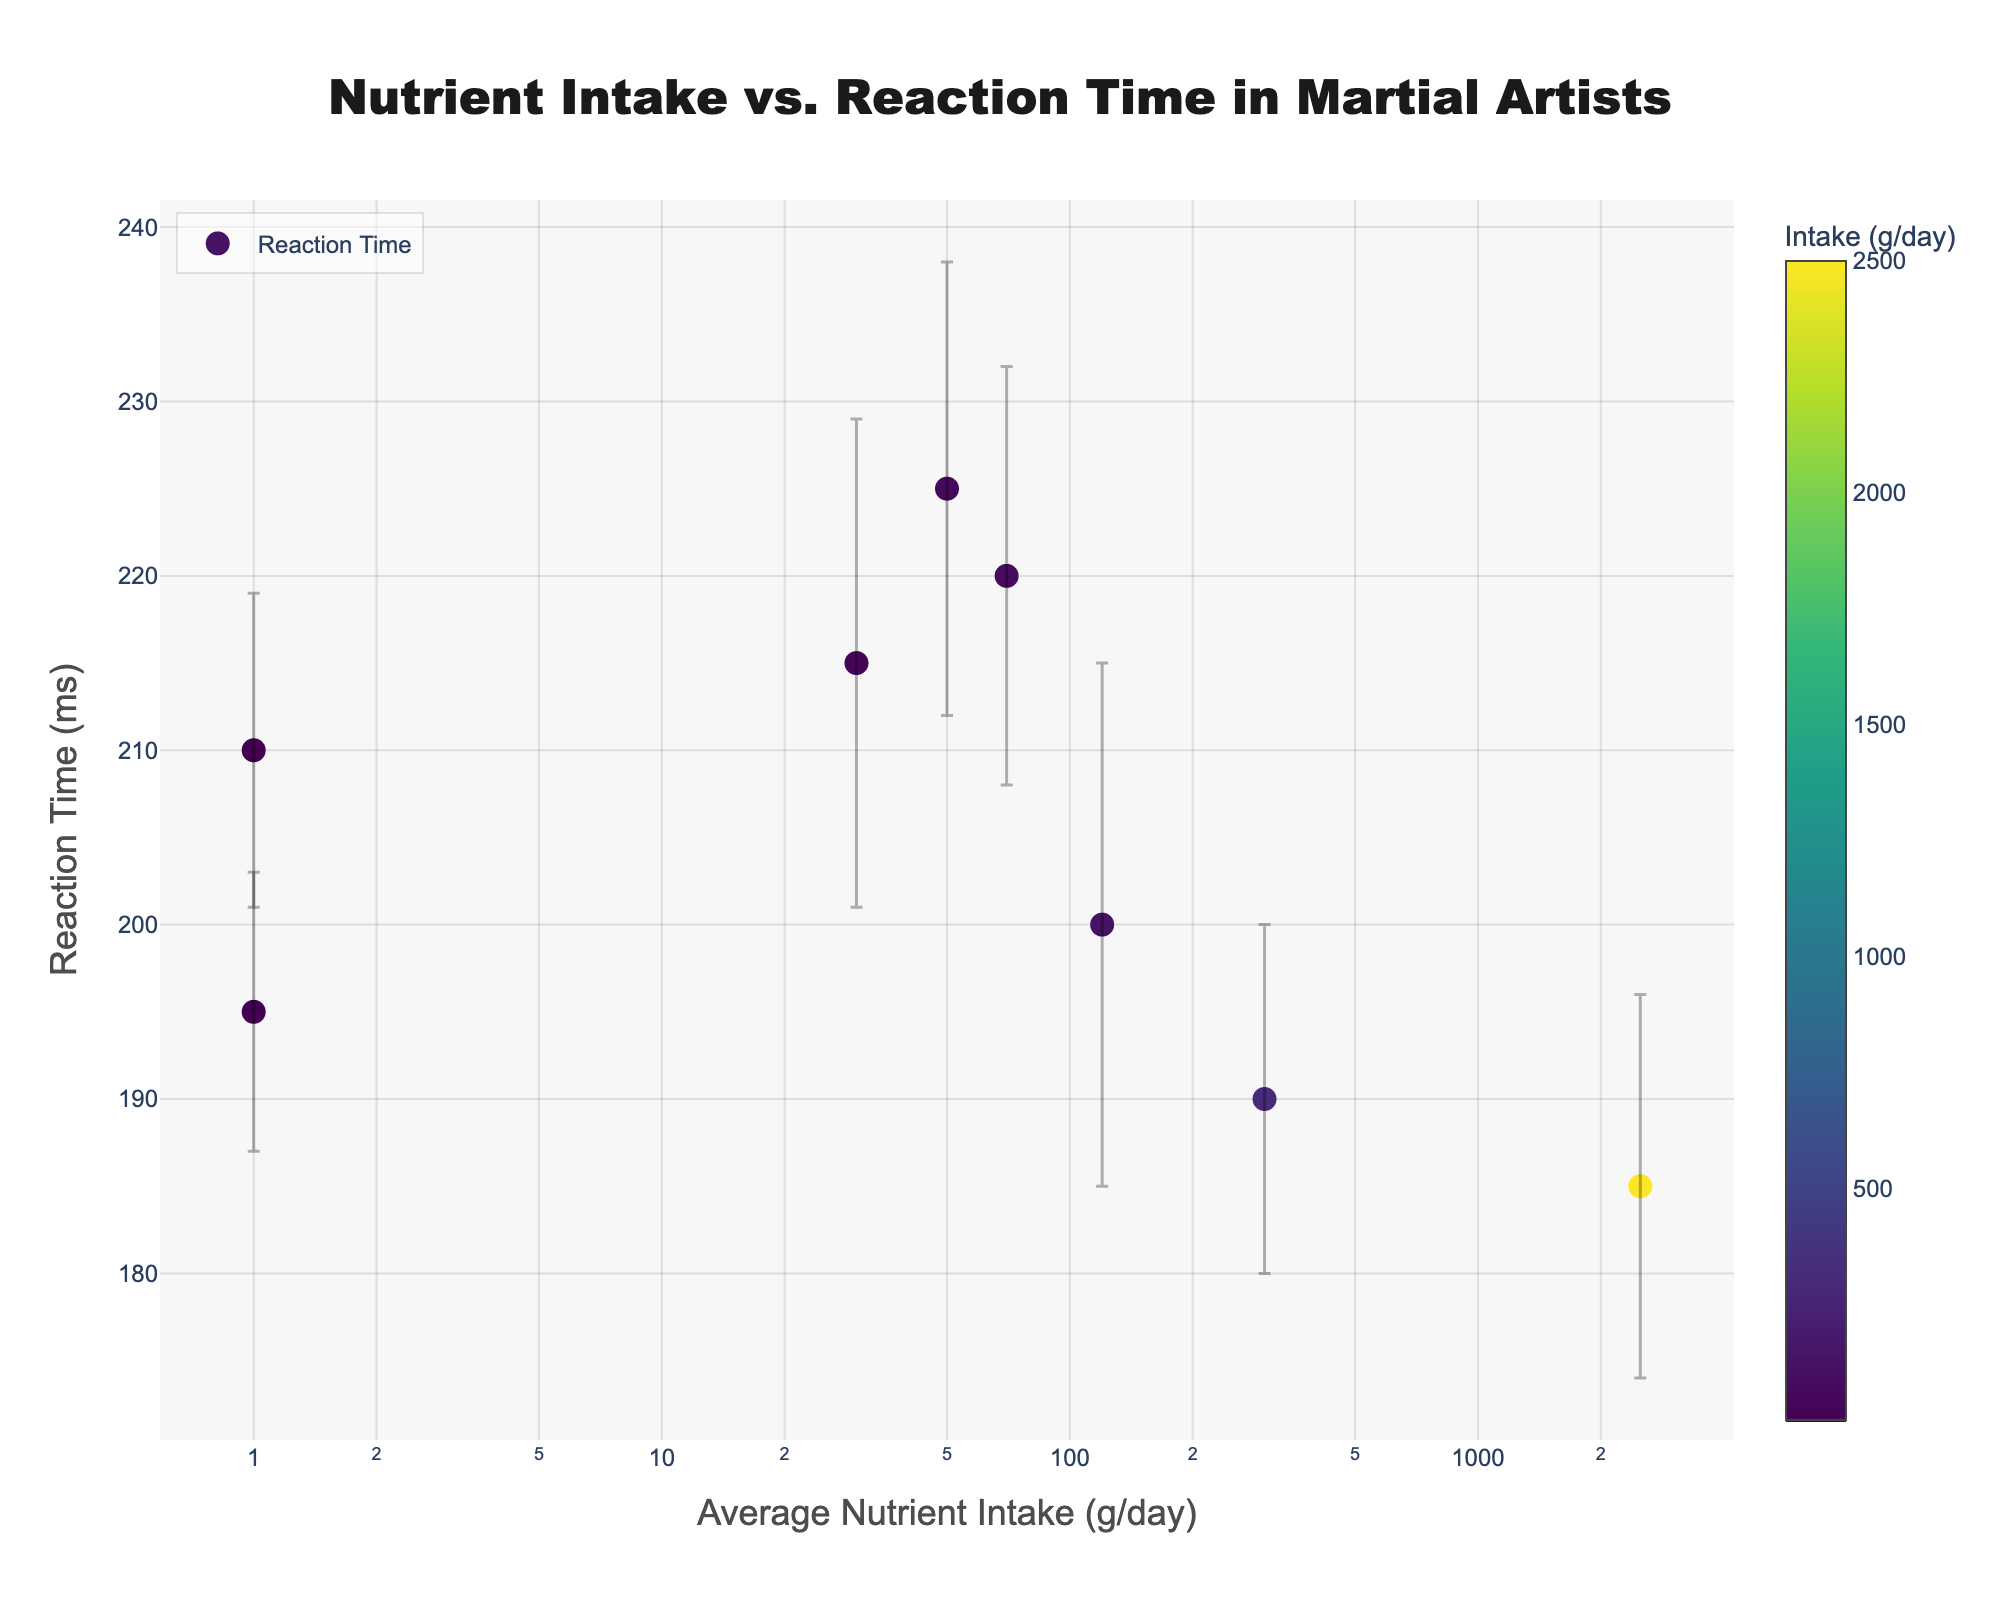What is the title of the plot? The title is displayed at the top of the figure and it describes what the plot is about.
Answer: Nutrient Intake vs. Reaction Time in Martial Artists What is the x-axis representing? The x-axis title is displayed below the horizontal axis and it describes what the x-axis values stand for.
Answer: Average Nutrient Intake (g/day) How many nutrients are displayed in the plot? Each dot represents a nutrient and we can see that there are dots for Protein, Carbohydrates, Fats, Vitamins, Minerals, Water, Fiber, and Sugars.
Answer: 8 Which nutrient has the lowest average reaction time? By checking the y-values of each dot, we see that the dot corresponding to Water has the lowest y-value, indicating the lowest reaction time.
Answer: Water What is the average reaction time for Carbohydrates? By hovering over the dot for Carbohydrates on the plot, it shows the reaction time value.
Answer: 190 ms Which nutrient has the highest variability in reaction time? The error bars show the variability in reaction time. The nutrient with the longest error bar has the highest variability. Fiber has the most extended error bars.
Answer: Fiber What is the range of reaction times for Protein given its standard deviation? The average reaction time for Protein is 200 ms with a standard deviation of 15 ms. The range is from (200 - 15) to (200 + 15).
Answer: 185 to 215 ms Which nutrient has a lower average reaction time, Fats or Vitamins? By comparing the y-values of the dots for Fats and Vitamins, we can see that Vitamins have a lower average reaction time.
Answer: Vitamins What is the average nutrient intake (g/day) of the nutrient with the highest reaction time? By identifying the dot on the furthest top of the plot, Sugars have the highest reaction time. Its x-value shows the intake.
Answer: 50 g/day For which nutrient is the error bar the shortest? Comparing the lengths of the error bars, Vitamins have the shortest error bar.
Answer: Vitamins 